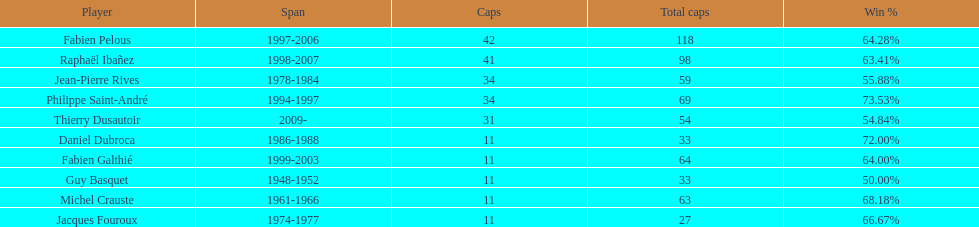Who had the largest win percentage? Philippe Saint-André. 